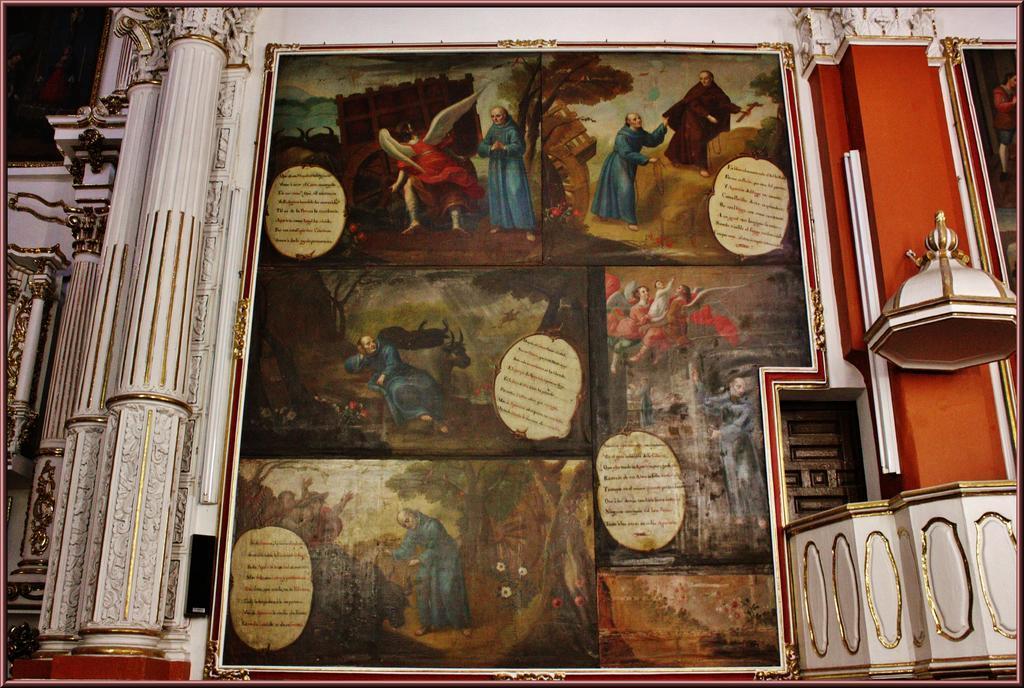Can you describe this image briefly? In this image, we can see an art on the wall. There are pillars on the left side of the image. 